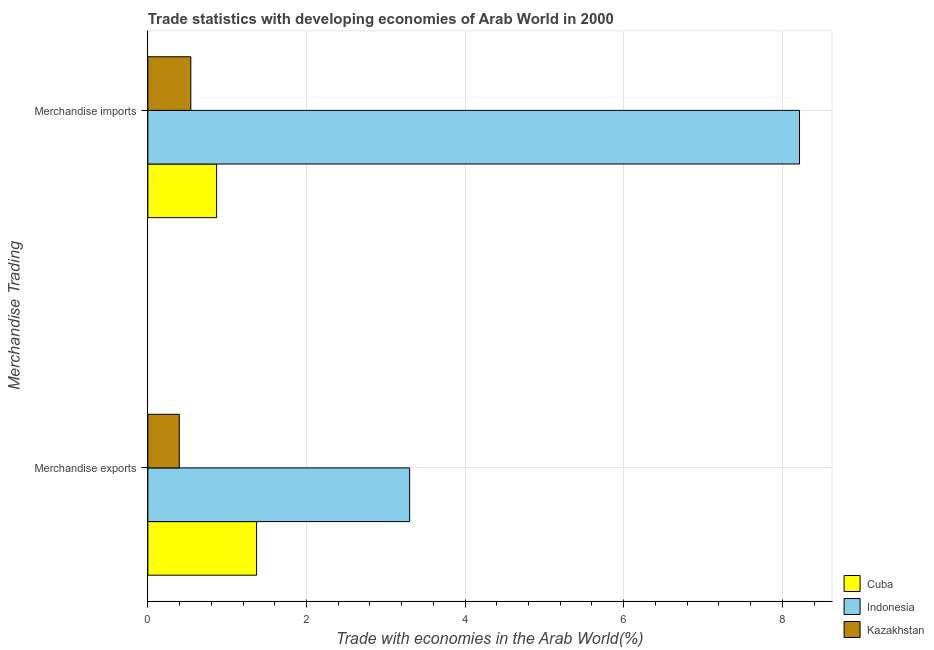How many groups of bars are there?
Offer a terse response. 2. Are the number of bars per tick equal to the number of legend labels?
Offer a terse response. Yes. How many bars are there on the 1st tick from the top?
Provide a succinct answer. 3. What is the label of the 2nd group of bars from the top?
Keep it short and to the point. Merchandise exports. What is the merchandise exports in Cuba?
Your response must be concise. 1.37. Across all countries, what is the maximum merchandise imports?
Offer a very short reply. 8.22. Across all countries, what is the minimum merchandise exports?
Make the answer very short. 0.4. In which country was the merchandise imports maximum?
Make the answer very short. Indonesia. In which country was the merchandise exports minimum?
Your answer should be very brief. Kazakhstan. What is the total merchandise exports in the graph?
Offer a very short reply. 5.07. What is the difference between the merchandise exports in Cuba and that in Indonesia?
Give a very brief answer. -1.93. What is the difference between the merchandise imports in Indonesia and the merchandise exports in Cuba?
Your response must be concise. 6.85. What is the average merchandise imports per country?
Provide a succinct answer. 3.21. What is the difference between the merchandise imports and merchandise exports in Kazakhstan?
Your answer should be compact. 0.15. In how many countries, is the merchandise exports greater than 7.6 %?
Offer a very short reply. 0. What is the ratio of the merchandise exports in Cuba to that in Kazakhstan?
Provide a short and direct response. 3.46. What does the 1st bar from the top in Merchandise exports represents?
Provide a short and direct response. Kazakhstan. Are all the bars in the graph horizontal?
Provide a short and direct response. Yes. What is the difference between two consecutive major ticks on the X-axis?
Provide a short and direct response. 2. Does the graph contain any zero values?
Ensure brevity in your answer.  No. Does the graph contain grids?
Your answer should be very brief. Yes. How are the legend labels stacked?
Ensure brevity in your answer.  Vertical. What is the title of the graph?
Offer a terse response. Trade statistics with developing economies of Arab World in 2000. Does "Liechtenstein" appear as one of the legend labels in the graph?
Your answer should be very brief. No. What is the label or title of the X-axis?
Make the answer very short. Trade with economies in the Arab World(%). What is the label or title of the Y-axis?
Make the answer very short. Merchandise Trading. What is the Trade with economies in the Arab World(%) in Cuba in Merchandise exports?
Offer a very short reply. 1.37. What is the Trade with economies in the Arab World(%) of Indonesia in Merchandise exports?
Your answer should be very brief. 3.3. What is the Trade with economies in the Arab World(%) in Kazakhstan in Merchandise exports?
Give a very brief answer. 0.4. What is the Trade with economies in the Arab World(%) of Cuba in Merchandise imports?
Ensure brevity in your answer.  0.87. What is the Trade with economies in the Arab World(%) of Indonesia in Merchandise imports?
Offer a very short reply. 8.22. What is the Trade with economies in the Arab World(%) of Kazakhstan in Merchandise imports?
Your answer should be very brief. 0.54. Across all Merchandise Trading, what is the maximum Trade with economies in the Arab World(%) in Cuba?
Offer a terse response. 1.37. Across all Merchandise Trading, what is the maximum Trade with economies in the Arab World(%) in Indonesia?
Offer a terse response. 8.22. Across all Merchandise Trading, what is the maximum Trade with economies in the Arab World(%) in Kazakhstan?
Offer a very short reply. 0.54. Across all Merchandise Trading, what is the minimum Trade with economies in the Arab World(%) of Cuba?
Your answer should be very brief. 0.87. Across all Merchandise Trading, what is the minimum Trade with economies in the Arab World(%) of Indonesia?
Provide a succinct answer. 3.3. Across all Merchandise Trading, what is the minimum Trade with economies in the Arab World(%) of Kazakhstan?
Provide a succinct answer. 0.4. What is the total Trade with economies in the Arab World(%) of Cuba in the graph?
Provide a succinct answer. 2.24. What is the total Trade with economies in the Arab World(%) of Indonesia in the graph?
Provide a short and direct response. 11.52. What is the total Trade with economies in the Arab World(%) in Kazakhstan in the graph?
Make the answer very short. 0.94. What is the difference between the Trade with economies in the Arab World(%) of Cuba in Merchandise exports and that in Merchandise imports?
Your answer should be very brief. 0.5. What is the difference between the Trade with economies in the Arab World(%) in Indonesia in Merchandise exports and that in Merchandise imports?
Keep it short and to the point. -4.92. What is the difference between the Trade with economies in the Arab World(%) of Kazakhstan in Merchandise exports and that in Merchandise imports?
Provide a short and direct response. -0.15. What is the difference between the Trade with economies in the Arab World(%) of Cuba in Merchandise exports and the Trade with economies in the Arab World(%) of Indonesia in Merchandise imports?
Provide a succinct answer. -6.85. What is the difference between the Trade with economies in the Arab World(%) in Cuba in Merchandise exports and the Trade with economies in the Arab World(%) in Kazakhstan in Merchandise imports?
Make the answer very short. 0.83. What is the difference between the Trade with economies in the Arab World(%) in Indonesia in Merchandise exports and the Trade with economies in the Arab World(%) in Kazakhstan in Merchandise imports?
Make the answer very short. 2.76. What is the average Trade with economies in the Arab World(%) in Cuba per Merchandise Trading?
Provide a short and direct response. 1.12. What is the average Trade with economies in the Arab World(%) of Indonesia per Merchandise Trading?
Your answer should be very brief. 5.76. What is the average Trade with economies in the Arab World(%) of Kazakhstan per Merchandise Trading?
Make the answer very short. 0.47. What is the difference between the Trade with economies in the Arab World(%) of Cuba and Trade with economies in the Arab World(%) of Indonesia in Merchandise exports?
Make the answer very short. -1.93. What is the difference between the Trade with economies in the Arab World(%) in Cuba and Trade with economies in the Arab World(%) in Kazakhstan in Merchandise exports?
Provide a succinct answer. 0.97. What is the difference between the Trade with economies in the Arab World(%) in Indonesia and Trade with economies in the Arab World(%) in Kazakhstan in Merchandise exports?
Offer a terse response. 2.9. What is the difference between the Trade with economies in the Arab World(%) of Cuba and Trade with economies in the Arab World(%) of Indonesia in Merchandise imports?
Your response must be concise. -7.35. What is the difference between the Trade with economies in the Arab World(%) in Cuba and Trade with economies in the Arab World(%) in Kazakhstan in Merchandise imports?
Keep it short and to the point. 0.33. What is the difference between the Trade with economies in the Arab World(%) in Indonesia and Trade with economies in the Arab World(%) in Kazakhstan in Merchandise imports?
Give a very brief answer. 7.67. What is the ratio of the Trade with economies in the Arab World(%) of Cuba in Merchandise exports to that in Merchandise imports?
Your answer should be very brief. 1.58. What is the ratio of the Trade with economies in the Arab World(%) in Indonesia in Merchandise exports to that in Merchandise imports?
Your answer should be compact. 0.4. What is the ratio of the Trade with economies in the Arab World(%) in Kazakhstan in Merchandise exports to that in Merchandise imports?
Make the answer very short. 0.73. What is the difference between the highest and the second highest Trade with economies in the Arab World(%) of Cuba?
Your response must be concise. 0.5. What is the difference between the highest and the second highest Trade with economies in the Arab World(%) of Indonesia?
Ensure brevity in your answer.  4.92. What is the difference between the highest and the second highest Trade with economies in the Arab World(%) of Kazakhstan?
Your answer should be compact. 0.15. What is the difference between the highest and the lowest Trade with economies in the Arab World(%) of Cuba?
Give a very brief answer. 0.5. What is the difference between the highest and the lowest Trade with economies in the Arab World(%) in Indonesia?
Offer a very short reply. 4.92. What is the difference between the highest and the lowest Trade with economies in the Arab World(%) in Kazakhstan?
Give a very brief answer. 0.15. 